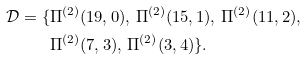<formula> <loc_0><loc_0><loc_500><loc_500>\mathcal { D } = \{ & \Pi ^ { ( 2 ) } ( 1 9 , 0 ) , \, \Pi ^ { ( 2 ) } ( 1 5 , 1 ) , \, \Pi ^ { ( 2 ) } ( 1 1 , 2 ) , \, \\ & \Pi ^ { ( 2 ) } ( 7 , 3 ) , \, \Pi ^ { ( 2 ) } ( 3 , 4 ) \} .</formula> 